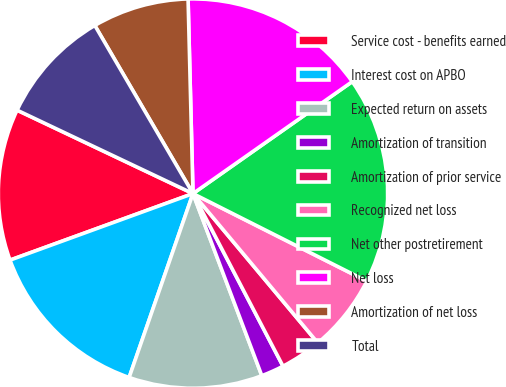Convert chart. <chart><loc_0><loc_0><loc_500><loc_500><pie_chart><fcel>Service cost - benefits earned<fcel>Interest cost on APBO<fcel>Expected return on assets<fcel>Amortization of transition<fcel>Amortization of prior service<fcel>Recognized net loss<fcel>Net other postretirement<fcel>Net loss<fcel>Amortization of net loss<fcel>Total<nl><fcel>12.6%<fcel>14.13%<fcel>11.07%<fcel>1.9%<fcel>3.43%<fcel>6.49%<fcel>17.18%<fcel>15.65%<fcel>8.01%<fcel>9.54%<nl></chart> 